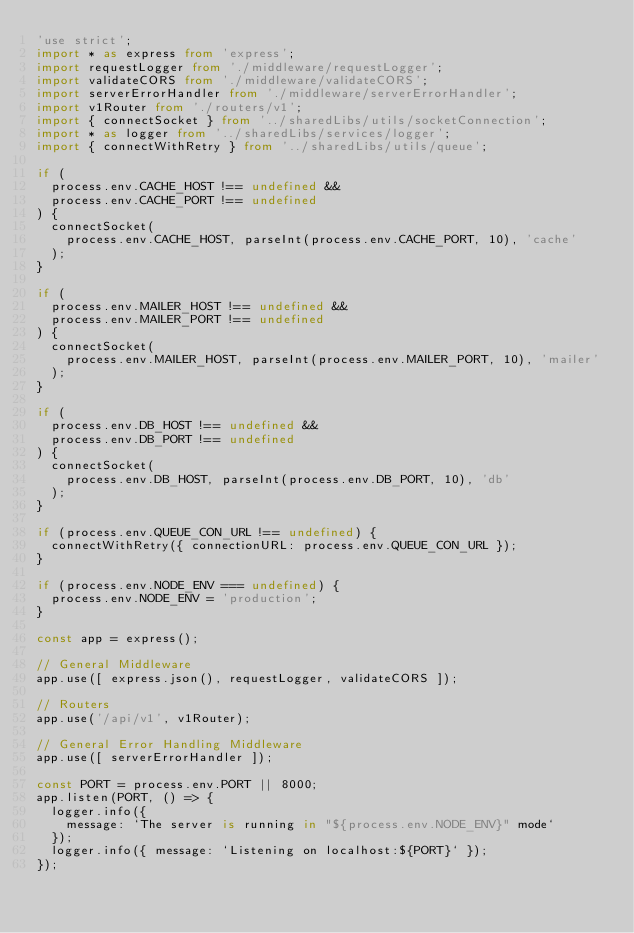<code> <loc_0><loc_0><loc_500><loc_500><_TypeScript_>'use strict';
import * as express from 'express';
import requestLogger from './middleware/requestLogger';
import validateCORS from './middleware/validateCORS';
import serverErrorHandler from './middleware/serverErrorHandler';
import v1Router from './routers/v1';
import { connectSocket } from '../sharedLibs/utils/socketConnection';
import * as logger from '../sharedLibs/services/logger';
import { connectWithRetry } from '../sharedLibs/utils/queue';

if (
  process.env.CACHE_HOST !== undefined &&
  process.env.CACHE_PORT !== undefined
) {
  connectSocket(
    process.env.CACHE_HOST, parseInt(process.env.CACHE_PORT, 10), 'cache'
  );
}

if (
  process.env.MAILER_HOST !== undefined &&
  process.env.MAILER_PORT !== undefined
) {
  connectSocket(
    process.env.MAILER_HOST, parseInt(process.env.MAILER_PORT, 10), 'mailer'
  );
}

if (
  process.env.DB_HOST !== undefined &&
  process.env.DB_PORT !== undefined
) {
  connectSocket(
    process.env.DB_HOST, parseInt(process.env.DB_PORT, 10), 'db'
  );
}

if (process.env.QUEUE_CON_URL !== undefined) {
  connectWithRetry({ connectionURL: process.env.QUEUE_CON_URL });
}

if (process.env.NODE_ENV === undefined) {
  process.env.NODE_ENV = 'production';
}

const app = express();

// General Middleware
app.use([ express.json(), requestLogger, validateCORS ]);

// Routers
app.use('/api/v1', v1Router);

// General Error Handling Middleware
app.use([ serverErrorHandler ]);

const PORT = process.env.PORT || 8000;
app.listen(PORT, () => {
  logger.info({
    message: `The server is running in "${process.env.NODE_ENV}" mode`
  });
  logger.info({ message: `Listening on localhost:${PORT}` });
});</code> 